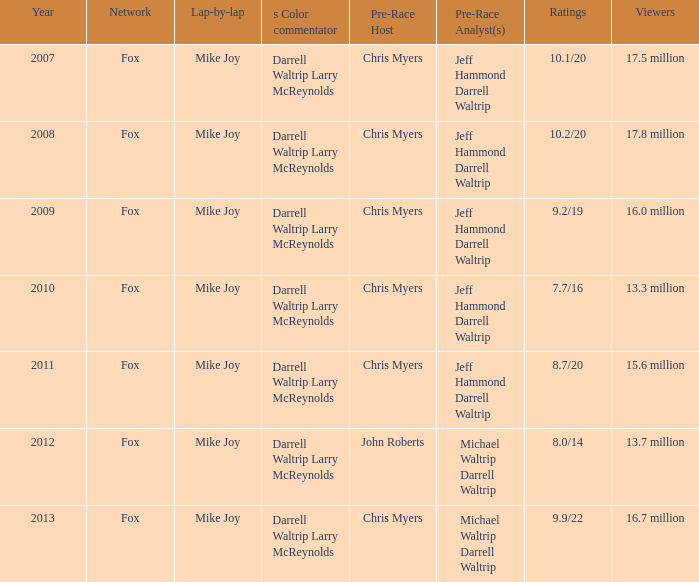7 million? 2012.0. Would you mind parsing the complete table? {'header': ['Year', 'Network', 'Lap-by-lap', 's Color commentator', 'Pre-Race Host', 'Pre-Race Analyst(s)', 'Ratings', 'Viewers'], 'rows': [['2007', 'Fox', 'Mike Joy', 'Darrell Waltrip Larry McReynolds', 'Chris Myers', 'Jeff Hammond Darrell Waltrip', '10.1/20', '17.5 million'], ['2008', 'Fox', 'Mike Joy', 'Darrell Waltrip Larry McReynolds', 'Chris Myers', 'Jeff Hammond Darrell Waltrip', '10.2/20', '17.8 million'], ['2009', 'Fox', 'Mike Joy', 'Darrell Waltrip Larry McReynolds', 'Chris Myers', 'Jeff Hammond Darrell Waltrip', '9.2/19', '16.0 million'], ['2010', 'Fox', 'Mike Joy', 'Darrell Waltrip Larry McReynolds', 'Chris Myers', 'Jeff Hammond Darrell Waltrip', '7.7/16', '13.3 million'], ['2011', 'Fox', 'Mike Joy', 'Darrell Waltrip Larry McReynolds', 'Chris Myers', 'Jeff Hammond Darrell Waltrip', '8.7/20', '15.6 million'], ['2012', 'Fox', 'Mike Joy', 'Darrell Waltrip Larry McReynolds', 'John Roberts', 'Michael Waltrip Darrell Waltrip', '8.0/14', '13.7 million'], ['2013', 'Fox', 'Mike Joy', 'Darrell Waltrip Larry McReynolds', 'Chris Myers', 'Michael Waltrip Darrell Waltrip', '9.9/22', '16.7 million']]} 